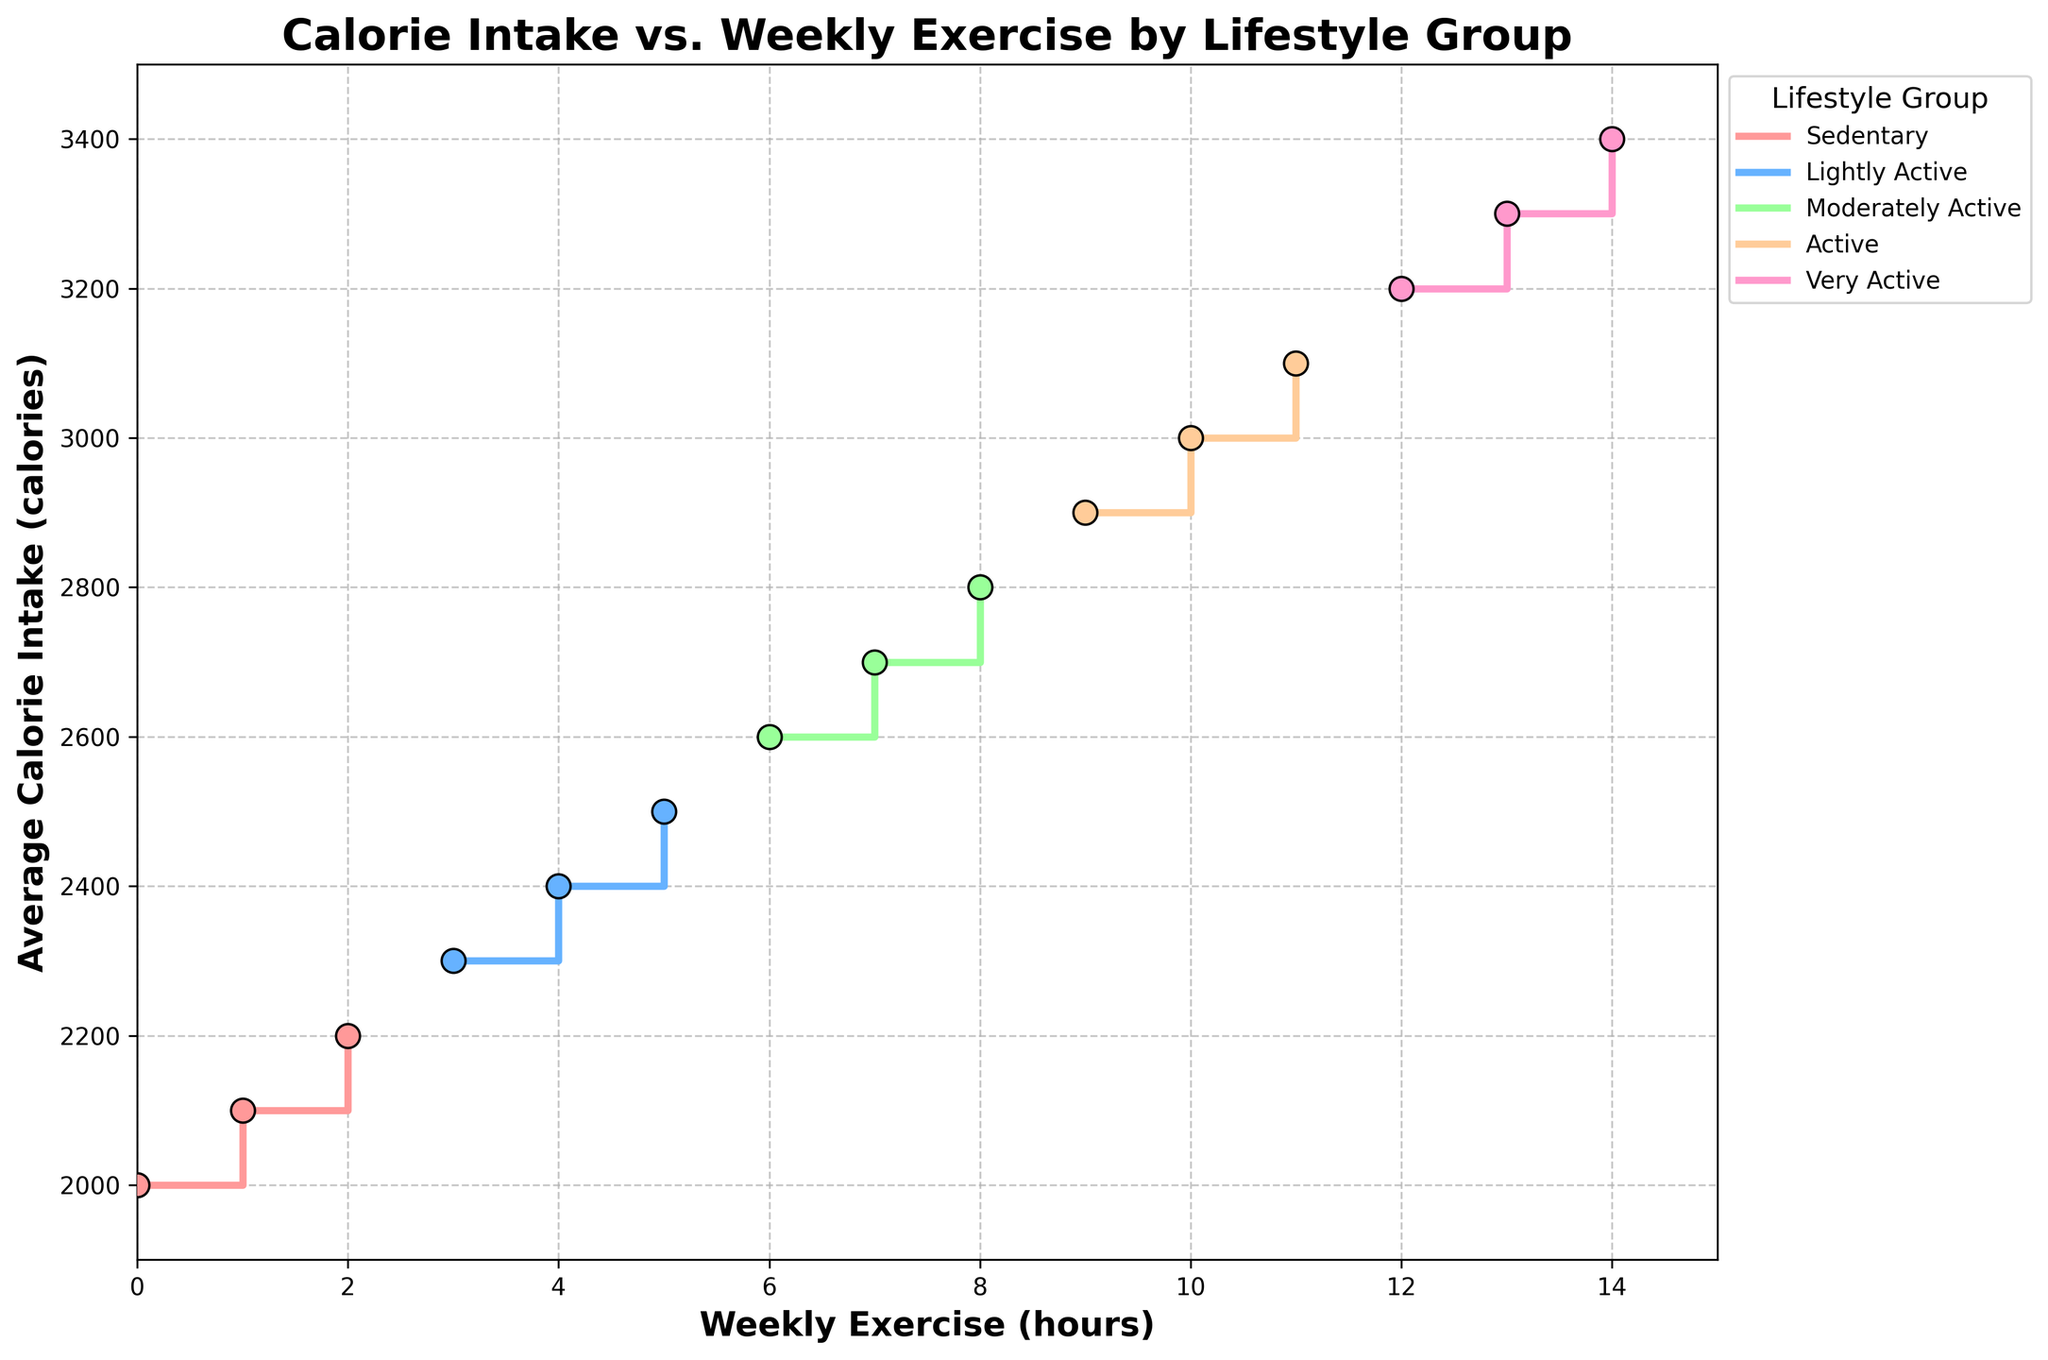what is the title of the figure? The title is displayed at the top of the figure in bold and larger font compared to the other text.
Answer: Calorie Intake vs. Weekly Exercise by Lifestyle Group how many lifestyle groups are represented in the figure? There are multiple unique colors and legend entries representing different lifestyle groups, each labeled distinctly.
Answer: 4 which lifestyle group has the highest average calorie intake and at how many hours of weekly exercise? By identifying the peak points in each step line and comparing the average calorie intake values listed beside them, the top value is seen.
Answer: Very Active, 14 hours how does the average calorie intake of the Sedentary group change with increasing weekly exercise? Trace the Sedentary group's step line from 0 to 2 hours of weekly exercise, observing the corresponding average calorie intake values at each step.
Answer: It increases from 2000 to 2200 calories which lifestyle group shows the highest increase in average calorie intake from the first to the last data point? For each group, subtract the average calorie intake at the first data point from the last data point, then compare these differences.
Answer: Very Active (increase of 1000 calories) how many hours of exercise does the Lightly Active group typically engage in weekly, and what's their average calorie intake range? Examine the step line and scatter points for the Lightly Active group to determine the minimum and maximum weekly exercise hours and the corresponding average calorie intake values.
Answer: 3 to 5 hours, 2300 to 2500 calories for the Moderately Active group, what’s the change in average calorie intake between 6 and 8 hours of weekly exercise? Look at the scatter points for the Moderately Active group at 6 and 8 hours, then compute the difference between the calorie intake values shown beside these points.
Answer: Increase of 200 calories which groups show overlapping average calorie intake ranges, and what are those ranges? Identify the overlapping regions by comparing the step lines and scatter points of different groups, focusing on where their average calorie intakes appear similar.
Answer: Lightly Active (2300-2500) and Moderately Active (2600-2800) what color is used for the Active group in the figure? Refer to the legend to match the label 'Active' with the corresponding colored line and scatter points.
Answer: Green how many unique data points are plotted for the Very Active group in the figure? Count the number of scatter points along the step line specific to the Very Active group as shown in the figure.
Answer: 3 